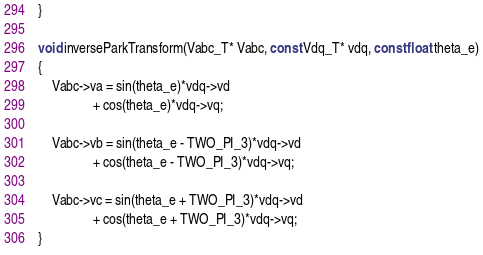<code> <loc_0><loc_0><loc_500><loc_500><_C_>}

void inverseParkTransform(Vabc_T* Vabc, const Vdq_T* vdq, const float theta_e)
{
    Vabc->va = sin(theta_e)*vdq->vd 
                + cos(theta_e)*vdq->vq;

    Vabc->vb = sin(theta_e - TWO_PI_3)*vdq->vd
                + cos(theta_e - TWO_PI_3)*vdq->vq;
    
    Vabc->vc = sin(theta_e + TWO_PI_3)*vdq->vd
                + cos(theta_e + TWO_PI_3)*vdq->vq;
}</code> 